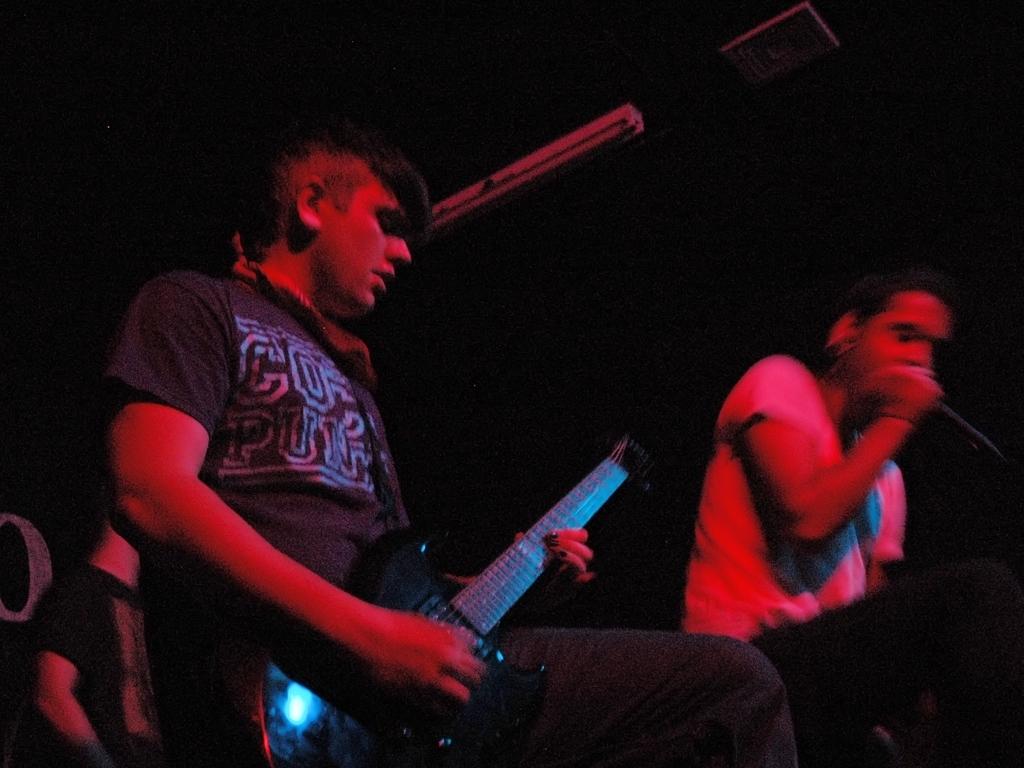Describe the lighting and its effect on the image. The image is dominated by a low-light environment, which casts the scene in deep shadows. The use of dim, possibly colored stage lighting creates a moody atmosphere congruent with musical performances in intimate venues. However, this lighting choice also contributes to the graininess and lack of detail, which affects the clarity of the image. 